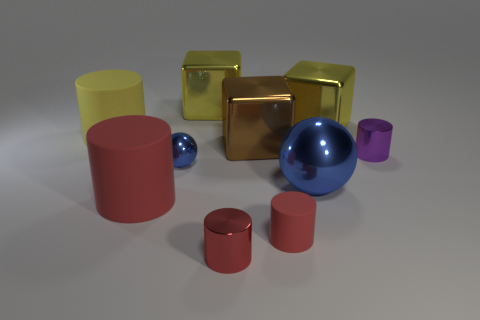Subtract all large yellow cylinders. How many cylinders are left? 4 Subtract all yellow cylinders. How many cylinders are left? 4 Subtract all cubes. How many objects are left? 7 Subtract 1 blocks. How many blocks are left? 2 Subtract all purple spheres. Subtract all purple blocks. How many spheres are left? 2 Subtract all blue cylinders. How many red blocks are left? 0 Subtract all brown objects. Subtract all small green cubes. How many objects are left? 9 Add 6 yellow metal objects. How many yellow metal objects are left? 8 Add 2 tiny purple shiny cylinders. How many tiny purple shiny cylinders exist? 3 Subtract 0 cyan cylinders. How many objects are left? 10 